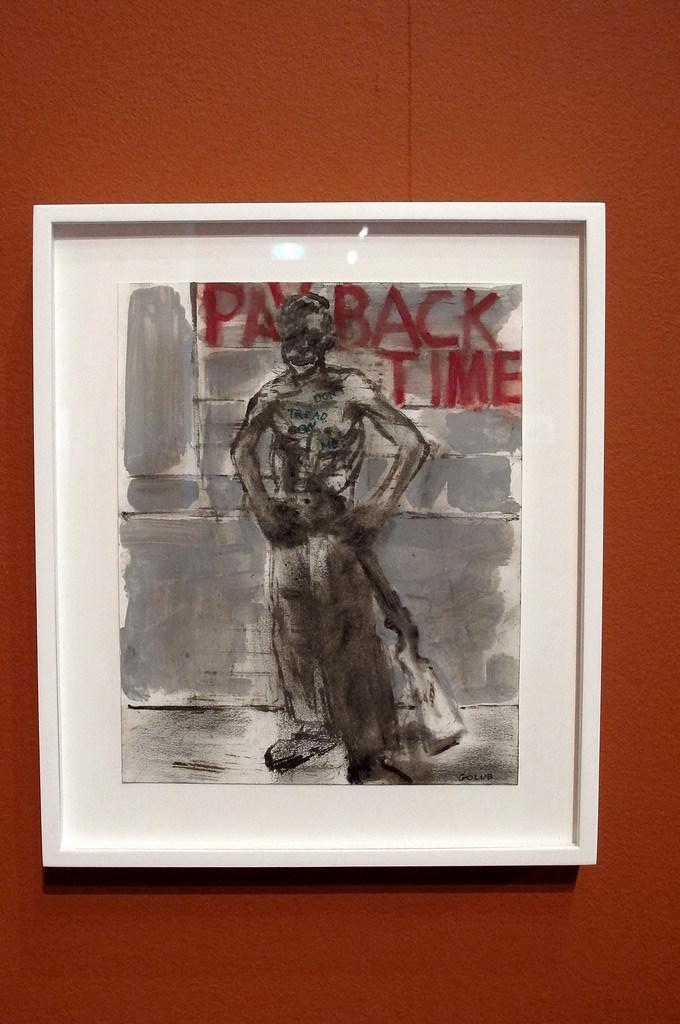<image>
Give a short and clear explanation of the subsequent image. A picture that says Pay Back Time in a white frame hanging on the wall. 